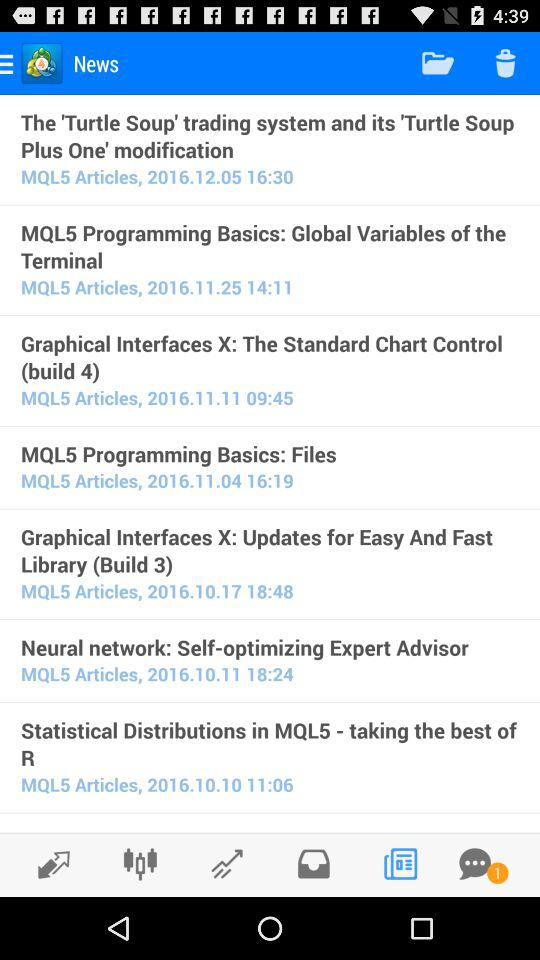On what date was the news "MQL5 Programming Basics: Global Variables of the Terminal" posted? The news "MQL5 Programming Basics: Global Variables of the Terminal" was posted on November 25, 2016. 